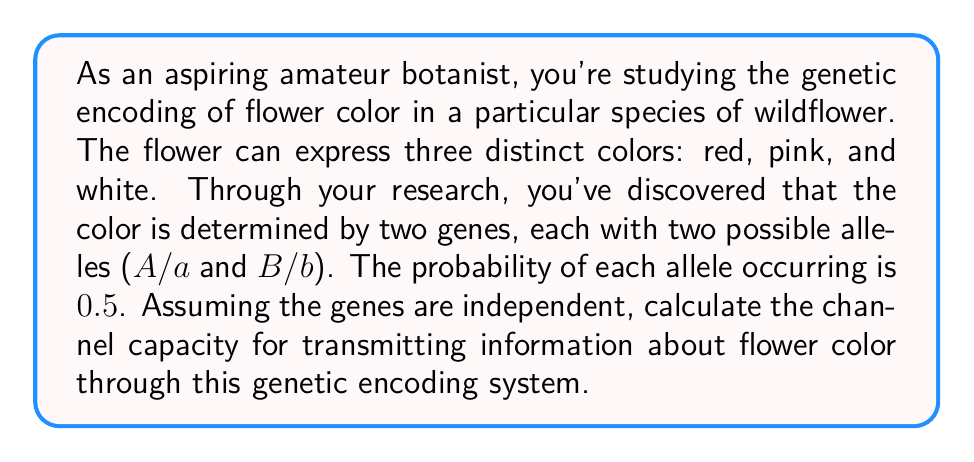Solve this math problem. To solve this problem, we'll follow these steps:

1) First, we need to determine the number of possible genotypes and their corresponding phenotypes (flower colors).

   Possible genotypes: AABB, AABb, AAbb, AaBB, AaBb, Aabb, aaBB, aaBb, aabb
   
   Let's assume:
   - AABB, AABb, AaBB result in red flowers
   - AAbb, AaBb, aaBB result in pink flowers
   - Aabb, aaBb, aabb result in white flowers

2) Now, we need to calculate the probability of each phenotype:

   P(red) = P(AABB) + P(AABb) + P(AaBB)
          = (0.5^4) + (0.5^4 * 2) + (0.5^4 * 2) = 0.25

   P(pink) = P(AAbb) + P(AaBb) + P(aaBB)
           = (0.5^4) + (0.5^4 * 4) + (0.5^4) = 0.375

   P(white) = P(Aabb) + P(aaBb) + P(aabb)
            = (0.5^4 * 2) + (0.5^4 * 2) + (0.5^4) = 0.375

3) The channel capacity is given by the maximum mutual information between the input (genotype) and output (phenotype). In this case, it's equivalent to the entropy of the output, which is calculated using the formula:

   $$H = -\sum_{i} p_i \log_2(p_i)$$

   where $p_i$ is the probability of each outcome.

4) Plugging in our values:

   $$H = -(0.25 \log_2(0.25) + 0.375 \log_2(0.375) + 0.375 \log_2(0.375))$$

5) Calculating:

   $$H = -(0.25 * (-2) + 0.375 * (-1.415) + 0.375 * (-1.415))$$
   $$H = 0.5 + 0.53 + 0.53 = 1.56$$

Therefore, the channel capacity for transmitting information about flower color through this genetic encoding system is approximately 1.56 bits.
Answer: 1.56 bits 